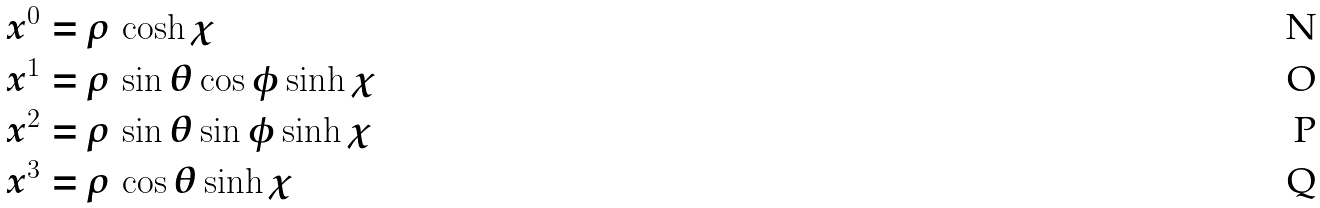Convert formula to latex. <formula><loc_0><loc_0><loc_500><loc_500>& x ^ { 0 } = \rho \, \cosh \chi \\ & x ^ { 1 } = \rho \, \sin \theta \cos \phi \sinh \chi \\ & x ^ { 2 } = \rho \, \sin \theta \sin \phi \sinh \chi \\ & x ^ { 3 } = \rho \, \cos \theta \sinh \chi</formula> 